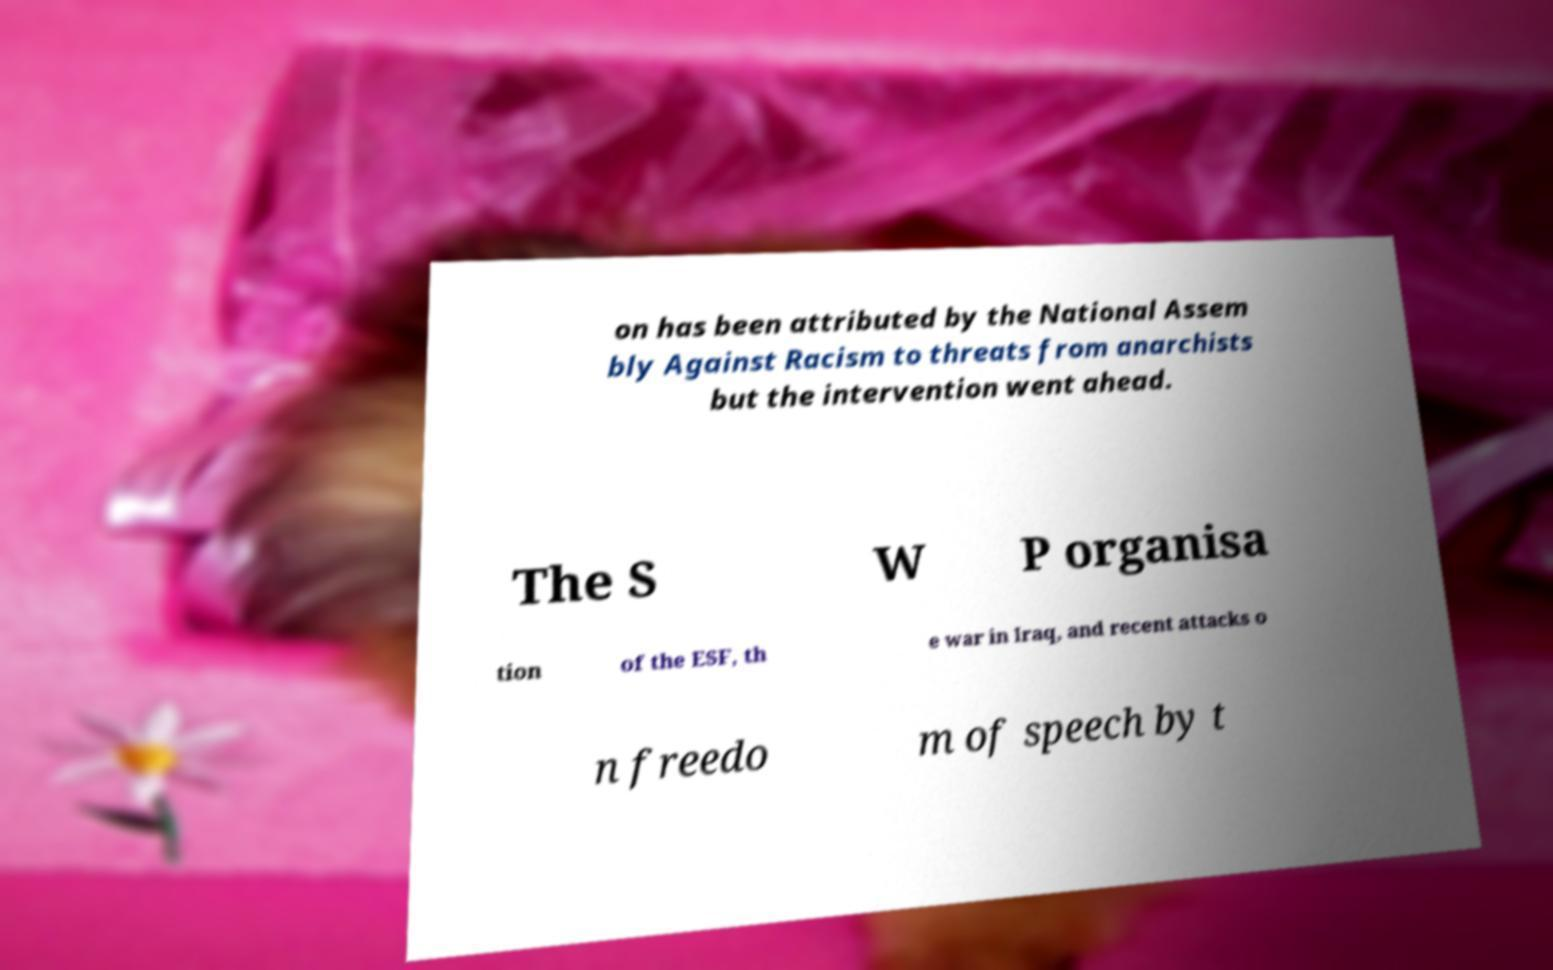Can you accurately transcribe the text from the provided image for me? on has been attributed by the National Assem bly Against Racism to threats from anarchists but the intervention went ahead. The S W P organisa tion of the ESF, th e war in Iraq, and recent attacks o n freedo m of speech by t 